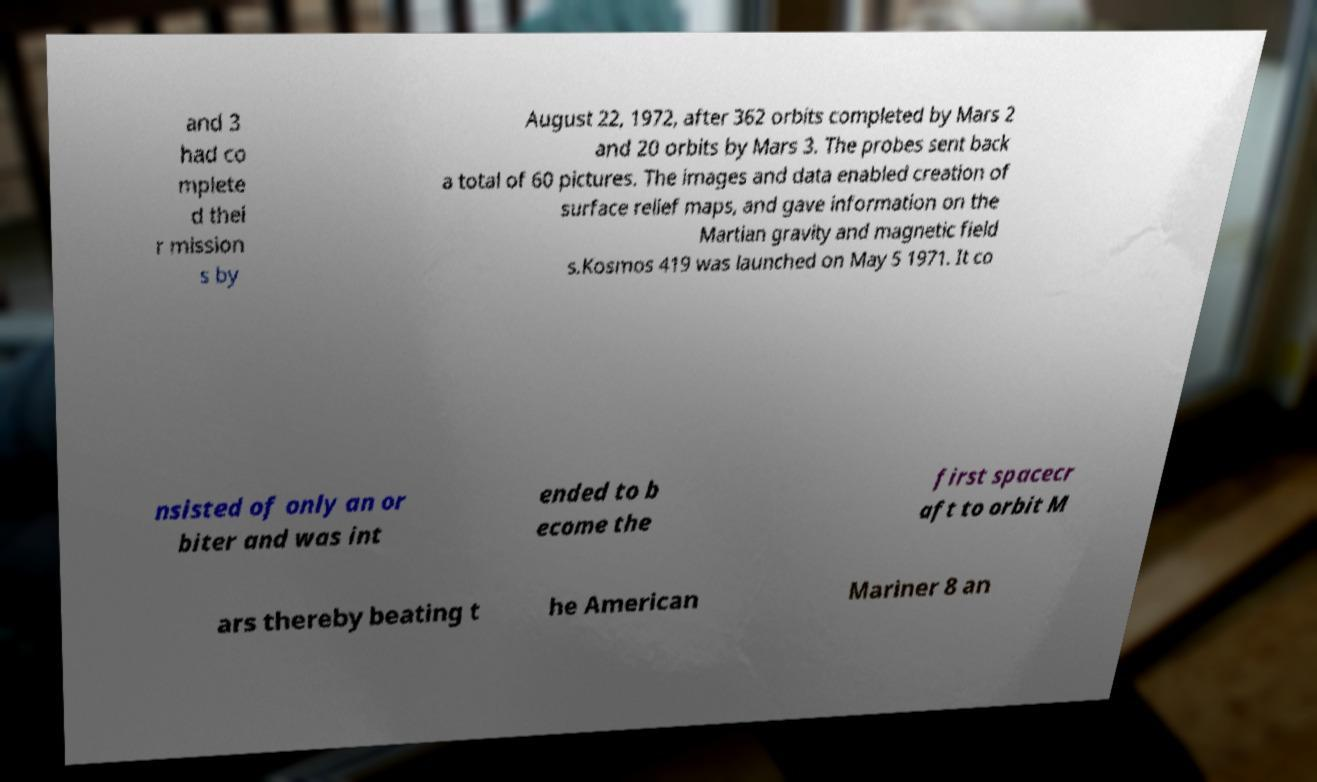Can you read and provide the text displayed in the image?This photo seems to have some interesting text. Can you extract and type it out for me? and 3 had co mplete d thei r mission s by August 22, 1972, after 362 orbits completed by Mars 2 and 20 orbits by Mars 3. The probes sent back a total of 60 pictures. The images and data enabled creation of surface relief maps, and gave information on the Martian gravity and magnetic field s.Kosmos 419 was launched on May 5 1971. It co nsisted of only an or biter and was int ended to b ecome the first spacecr aft to orbit M ars thereby beating t he American Mariner 8 an 